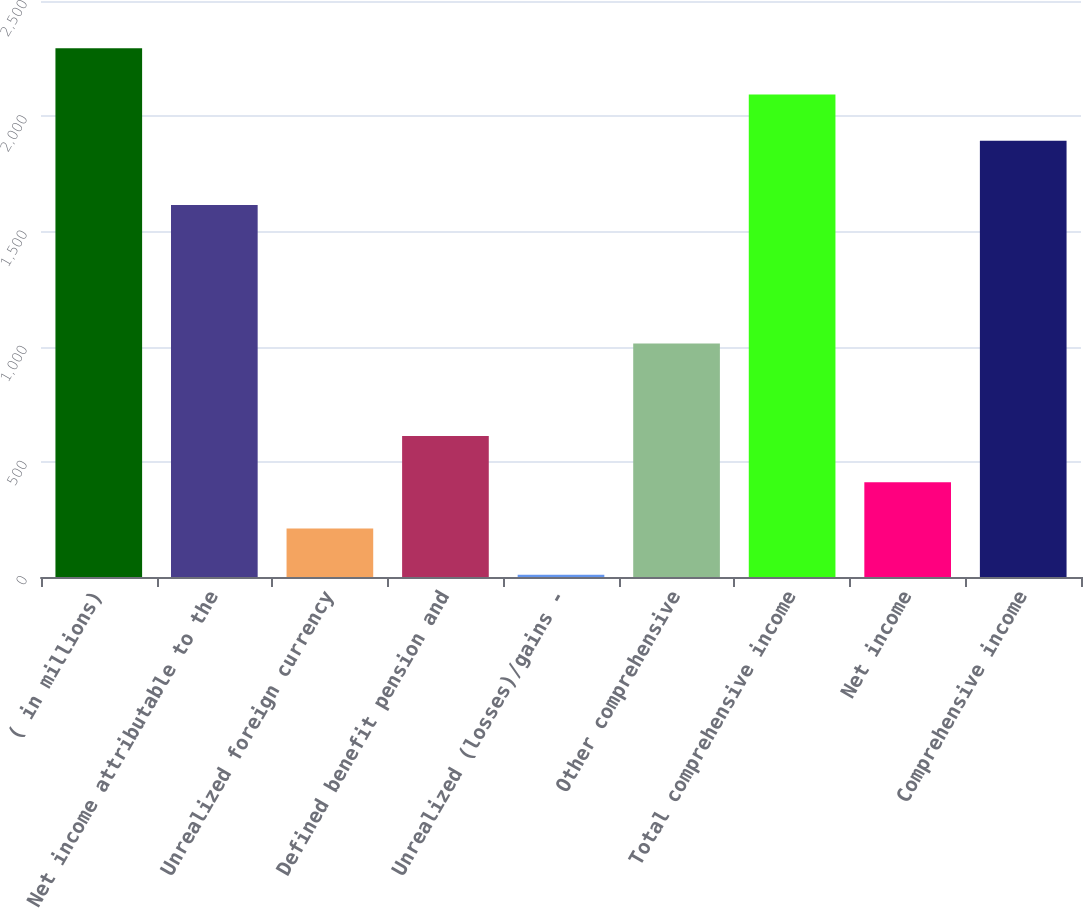<chart> <loc_0><loc_0><loc_500><loc_500><bar_chart><fcel>( in millions)<fcel>Net income attributable to the<fcel>Unrealized foreign currency<fcel>Defined benefit pension and<fcel>Unrealized (losses)/gains -<fcel>Other comprehensive<fcel>Total comprehensive income<fcel>Net income<fcel>Comprehensive income<nl><fcel>2294.4<fcel>1615<fcel>210.7<fcel>612.1<fcel>10<fcel>1013.5<fcel>2093.7<fcel>411.4<fcel>1893<nl></chart> 